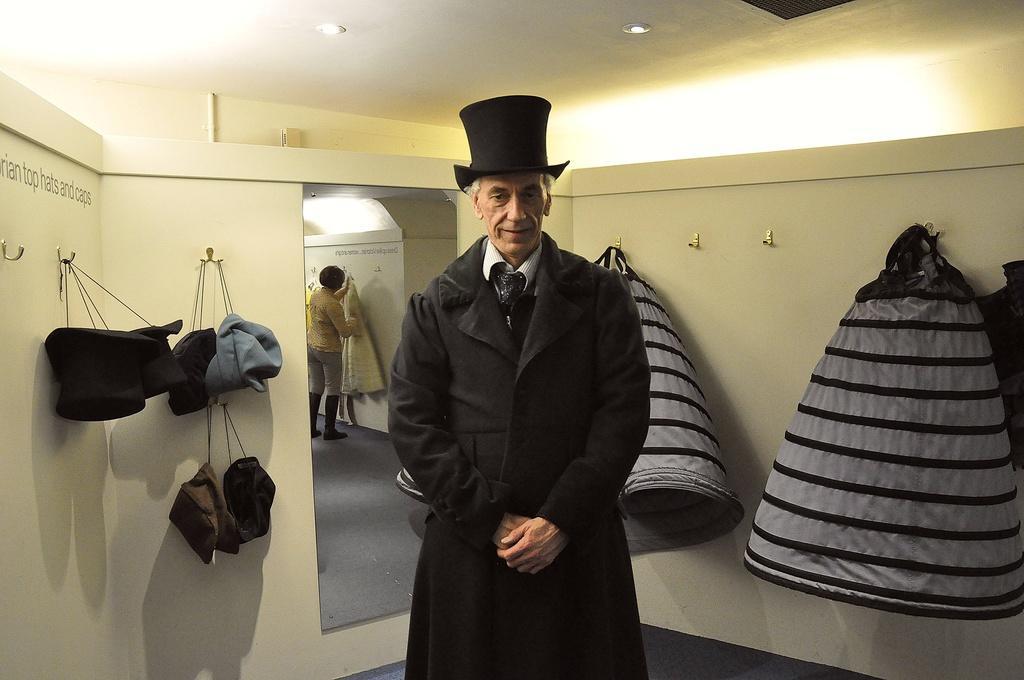How would you summarize this image in a sentence or two? In this image I can see the person standing and the person is wearing black color dress and I can see few hats and bags are hanged to the hooks. In the background I can see the mirror and I can also see the person in the mirror. 